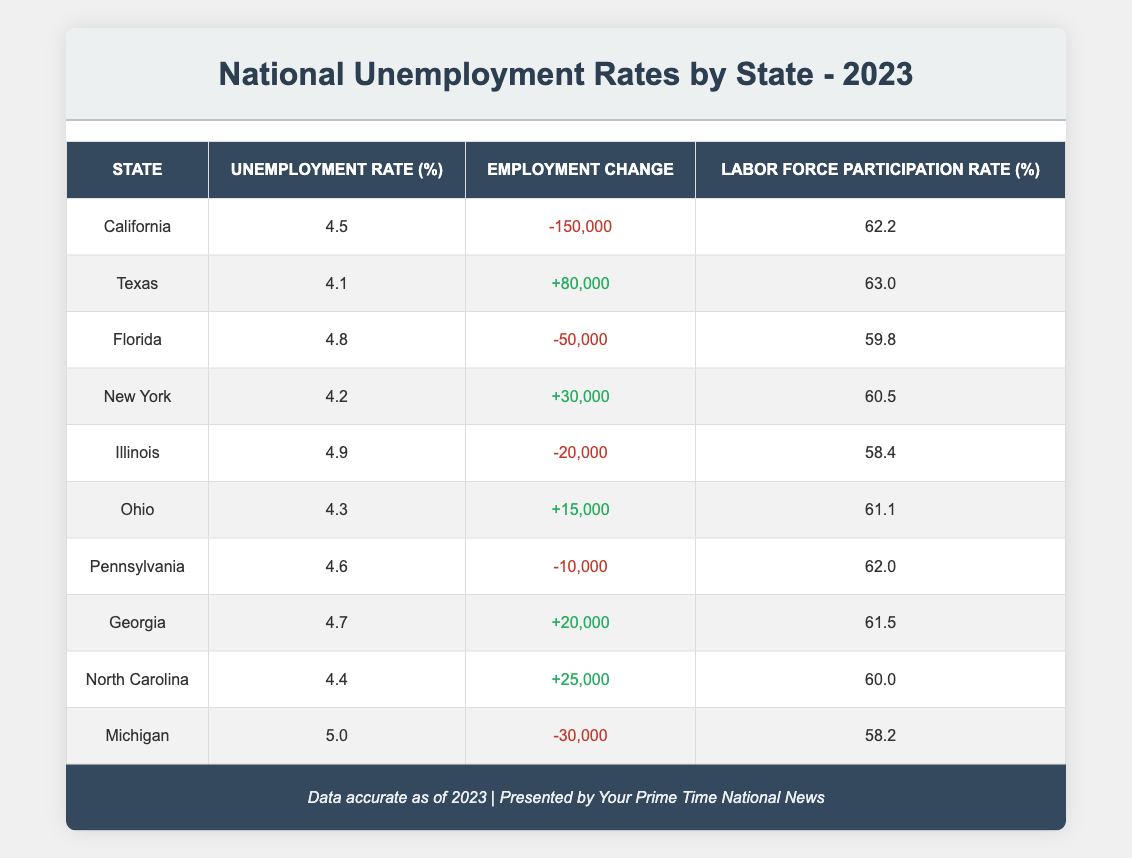What is the unemployment rate in Texas? According to the table, the unemployment rate for Texas is listed in the corresponding row under the "Unemployment Rate (%)" column, which shows 4.1.
Answer: 4.1 Which state has the highest unemployment rate? By examining the "Unemployment Rate (%)" column, Michigan has the highest value listed at 5.0.
Answer: Michigan What is the total employment change for Georgia and Ohio combined? The employment change for Georgia is +20,000 and for Ohio is +15,000. Adding these figures together gives (+20,000 + 15,000) = +35,000.
Answer: +35,000 Is the labor force participation rate in Florida higher than that in Pennsylvania? The table indicates that Florida's labor force participation rate is 59.8% while Pennsylvania's is 62.0%. Since 59.8% is less than 62.0%, the statement is false.
Answer: No Which state experienced the greatest job losses in 2023? Looking at the "Employment Change" column, California had the largest loss at -150,000, which is more than any other state listed in the table.
Answer: California What is the average unemployment rate of the states listed? To find the average, add all unemployment rates: (4.5 + 4.1 + 4.8 + 4.2 + 4.9 + 4.3 + 4.6 + 4.7 + 4.4 + 5.0) = 47.5. Now divide by the number of states (10): 47.5 / 10 = 4.75.
Answer: 4.75 Does North Carolina have a higher labor force participation rate than California? North Carolina's labor force participation rate is 60.0%, while California's is 62.2%. Since 60.0% is less than 62.2%, the statement is false.
Answer: No What is the difference in unemployment rates between Illinois and New York? The unemployment rate for Illinois is 4.9% and for New York is 4.2%. The difference is (4.9 - 4.2) = 0.7.
Answer: 0.7 How many states reported a positive employment change? The states with positive employment changes are Texas (+80,000), New York (+30,000), Ohio (+15,000), Georgia (+20,000), and North Carolina (+25,000), totaling five states.
Answer: 5 